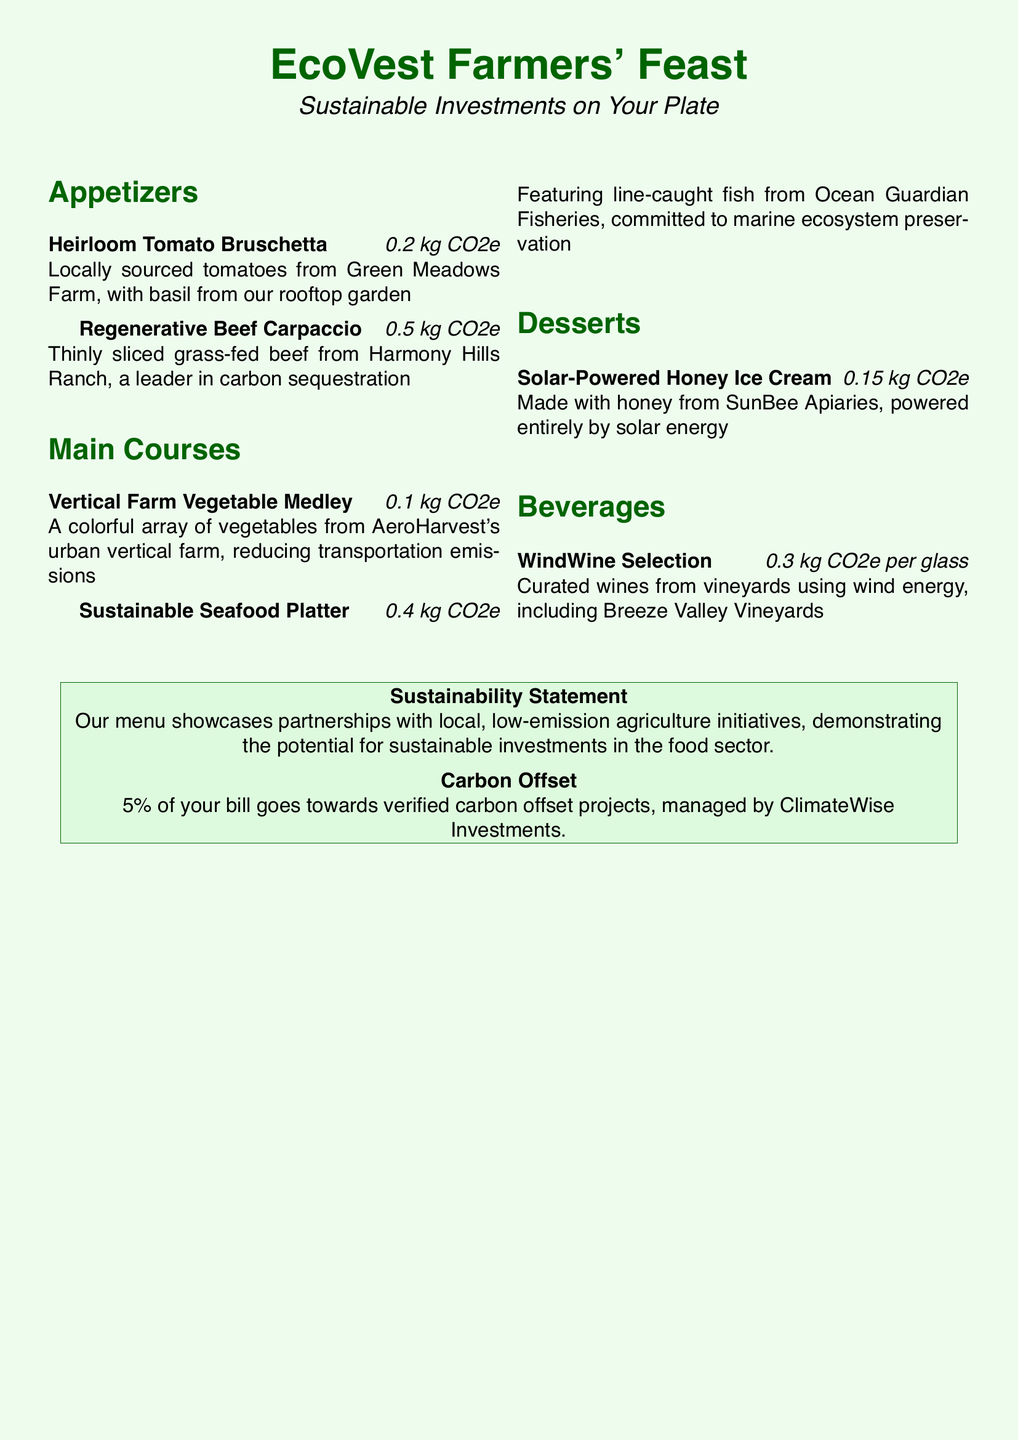What is the name of the buffet? The name of the buffet is prominently displayed at the top of the menu.
Answer: EcoVest Farmers' Feast Which farm supplies the heirloom tomatoes? The specific farm providing the heirloom tomatoes is mentioned under the appetizer section.
Answer: Green Meadows Farm What is the CO2e for the Sustainable Seafood Platter? The CO2e value for each dish is provided next to its name in the main courses section.
Answer: 0.4 kg CO2e What type of energy powers the honey ice cream production? The production method and energy source for the ice cream are described in the dessert section.
Answer: Solar energy How much of your bill goes to carbon offset projects? The menu states a percentage of the bill designated for carbon offset projects in the sustainability statement.
Answer: 5% Which farm is recognized for carbon sequestration in their beef? The document specifies the farm known for this practice under the appetizers.
Answer: Harmony Hills Ranch What kind of vegetables are used in the Vertical Farm Vegetable Medley? The medley description specifies the growing method, implying the type of vegetables.
Answer: Vegetables from AeroHarvest's urban vertical farm Which vineyard uses wind energy for its wine? The beverage section names a vineyard that uses renewable energy.
Answer: Breeze Valley Vineyards 